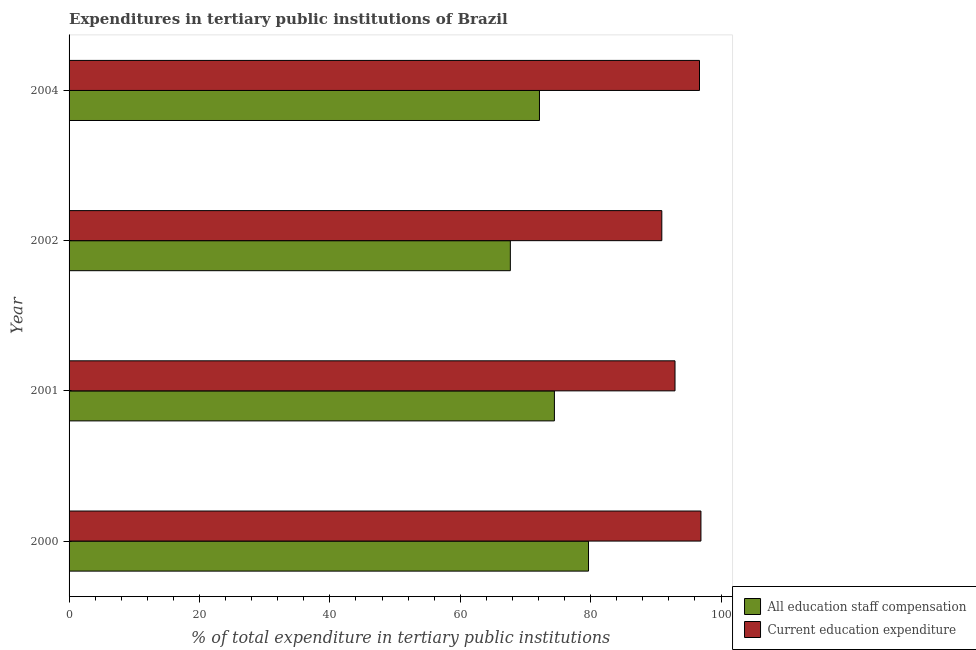How many different coloured bars are there?
Provide a short and direct response. 2. How many groups of bars are there?
Provide a succinct answer. 4. Are the number of bars per tick equal to the number of legend labels?
Your response must be concise. Yes. How many bars are there on the 4th tick from the top?
Your answer should be very brief. 2. In how many cases, is the number of bars for a given year not equal to the number of legend labels?
Give a very brief answer. 0. What is the expenditure in education in 2000?
Ensure brevity in your answer.  96.92. Across all years, what is the maximum expenditure in education?
Provide a short and direct response. 96.92. Across all years, what is the minimum expenditure in education?
Provide a succinct answer. 90.92. In which year was the expenditure in staff compensation maximum?
Your answer should be compact. 2000. What is the total expenditure in staff compensation in the graph?
Provide a succinct answer. 293.95. What is the difference between the expenditure in education in 2000 and that in 2001?
Your answer should be compact. 3.98. What is the difference between the expenditure in education in 2004 and the expenditure in staff compensation in 2000?
Offer a very short reply. 17.02. What is the average expenditure in staff compensation per year?
Your answer should be compact. 73.49. In the year 2000, what is the difference between the expenditure in staff compensation and expenditure in education?
Give a very brief answer. -17.24. In how many years, is the expenditure in education greater than 96 %?
Make the answer very short. 2. What is the ratio of the expenditure in education in 2000 to that in 2001?
Offer a terse response. 1.04. Is the expenditure in staff compensation in 2002 less than that in 2004?
Your answer should be compact. Yes. Is the difference between the expenditure in staff compensation in 2000 and 2002 greater than the difference between the expenditure in education in 2000 and 2002?
Ensure brevity in your answer.  Yes. What is the difference between the highest and the second highest expenditure in staff compensation?
Provide a succinct answer. 5.23. What is the difference between the highest and the lowest expenditure in staff compensation?
Your response must be concise. 11.99. In how many years, is the expenditure in staff compensation greater than the average expenditure in staff compensation taken over all years?
Provide a succinct answer. 2. Is the sum of the expenditure in staff compensation in 2001 and 2004 greater than the maximum expenditure in education across all years?
Provide a succinct answer. Yes. What does the 1st bar from the top in 2002 represents?
Your response must be concise. Current education expenditure. What does the 2nd bar from the bottom in 2002 represents?
Offer a very short reply. Current education expenditure. How many bars are there?
Offer a terse response. 8. Does the graph contain grids?
Keep it short and to the point. No. What is the title of the graph?
Your answer should be very brief. Expenditures in tertiary public institutions of Brazil. Does "Revenue" appear as one of the legend labels in the graph?
Your answer should be very brief. No. What is the label or title of the X-axis?
Give a very brief answer. % of total expenditure in tertiary public institutions. What is the label or title of the Y-axis?
Keep it short and to the point. Year. What is the % of total expenditure in tertiary public institutions of All education staff compensation in 2000?
Provide a short and direct response. 79.67. What is the % of total expenditure in tertiary public institutions of Current education expenditure in 2000?
Your answer should be compact. 96.92. What is the % of total expenditure in tertiary public institutions in All education staff compensation in 2001?
Offer a terse response. 74.44. What is the % of total expenditure in tertiary public institutions in Current education expenditure in 2001?
Provide a succinct answer. 92.94. What is the % of total expenditure in tertiary public institutions of All education staff compensation in 2002?
Provide a short and direct response. 67.68. What is the % of total expenditure in tertiary public institutions of Current education expenditure in 2002?
Provide a short and direct response. 90.92. What is the % of total expenditure in tertiary public institutions of All education staff compensation in 2004?
Your response must be concise. 72.15. What is the % of total expenditure in tertiary public institutions in Current education expenditure in 2004?
Provide a succinct answer. 96.7. Across all years, what is the maximum % of total expenditure in tertiary public institutions of All education staff compensation?
Offer a very short reply. 79.67. Across all years, what is the maximum % of total expenditure in tertiary public institutions in Current education expenditure?
Make the answer very short. 96.92. Across all years, what is the minimum % of total expenditure in tertiary public institutions of All education staff compensation?
Offer a very short reply. 67.68. Across all years, what is the minimum % of total expenditure in tertiary public institutions in Current education expenditure?
Provide a short and direct response. 90.92. What is the total % of total expenditure in tertiary public institutions of All education staff compensation in the graph?
Offer a very short reply. 293.95. What is the total % of total expenditure in tertiary public institutions of Current education expenditure in the graph?
Provide a succinct answer. 377.47. What is the difference between the % of total expenditure in tertiary public institutions of All education staff compensation in 2000 and that in 2001?
Give a very brief answer. 5.23. What is the difference between the % of total expenditure in tertiary public institutions of Current education expenditure in 2000 and that in 2001?
Offer a terse response. 3.98. What is the difference between the % of total expenditure in tertiary public institutions of All education staff compensation in 2000 and that in 2002?
Offer a very short reply. 11.99. What is the difference between the % of total expenditure in tertiary public institutions of Current education expenditure in 2000 and that in 2002?
Your answer should be very brief. 6. What is the difference between the % of total expenditure in tertiary public institutions of All education staff compensation in 2000 and that in 2004?
Give a very brief answer. 7.52. What is the difference between the % of total expenditure in tertiary public institutions in Current education expenditure in 2000 and that in 2004?
Your answer should be very brief. 0.22. What is the difference between the % of total expenditure in tertiary public institutions of All education staff compensation in 2001 and that in 2002?
Keep it short and to the point. 6.76. What is the difference between the % of total expenditure in tertiary public institutions of Current education expenditure in 2001 and that in 2002?
Provide a short and direct response. 2.02. What is the difference between the % of total expenditure in tertiary public institutions in All education staff compensation in 2001 and that in 2004?
Your answer should be very brief. 2.29. What is the difference between the % of total expenditure in tertiary public institutions of Current education expenditure in 2001 and that in 2004?
Ensure brevity in your answer.  -3.76. What is the difference between the % of total expenditure in tertiary public institutions of All education staff compensation in 2002 and that in 2004?
Give a very brief answer. -4.47. What is the difference between the % of total expenditure in tertiary public institutions of Current education expenditure in 2002 and that in 2004?
Your answer should be very brief. -5.78. What is the difference between the % of total expenditure in tertiary public institutions of All education staff compensation in 2000 and the % of total expenditure in tertiary public institutions of Current education expenditure in 2001?
Make the answer very short. -13.27. What is the difference between the % of total expenditure in tertiary public institutions of All education staff compensation in 2000 and the % of total expenditure in tertiary public institutions of Current education expenditure in 2002?
Your response must be concise. -11.24. What is the difference between the % of total expenditure in tertiary public institutions of All education staff compensation in 2000 and the % of total expenditure in tertiary public institutions of Current education expenditure in 2004?
Provide a succinct answer. -17.02. What is the difference between the % of total expenditure in tertiary public institutions of All education staff compensation in 2001 and the % of total expenditure in tertiary public institutions of Current education expenditure in 2002?
Offer a very short reply. -16.48. What is the difference between the % of total expenditure in tertiary public institutions in All education staff compensation in 2001 and the % of total expenditure in tertiary public institutions in Current education expenditure in 2004?
Provide a succinct answer. -22.26. What is the difference between the % of total expenditure in tertiary public institutions of All education staff compensation in 2002 and the % of total expenditure in tertiary public institutions of Current education expenditure in 2004?
Offer a very short reply. -29.01. What is the average % of total expenditure in tertiary public institutions in All education staff compensation per year?
Offer a very short reply. 73.49. What is the average % of total expenditure in tertiary public institutions of Current education expenditure per year?
Ensure brevity in your answer.  94.37. In the year 2000, what is the difference between the % of total expenditure in tertiary public institutions of All education staff compensation and % of total expenditure in tertiary public institutions of Current education expenditure?
Offer a very short reply. -17.24. In the year 2001, what is the difference between the % of total expenditure in tertiary public institutions in All education staff compensation and % of total expenditure in tertiary public institutions in Current education expenditure?
Your answer should be very brief. -18.5. In the year 2002, what is the difference between the % of total expenditure in tertiary public institutions in All education staff compensation and % of total expenditure in tertiary public institutions in Current education expenditure?
Provide a short and direct response. -23.23. In the year 2004, what is the difference between the % of total expenditure in tertiary public institutions of All education staff compensation and % of total expenditure in tertiary public institutions of Current education expenditure?
Ensure brevity in your answer.  -24.55. What is the ratio of the % of total expenditure in tertiary public institutions in All education staff compensation in 2000 to that in 2001?
Give a very brief answer. 1.07. What is the ratio of the % of total expenditure in tertiary public institutions of Current education expenditure in 2000 to that in 2001?
Give a very brief answer. 1.04. What is the ratio of the % of total expenditure in tertiary public institutions of All education staff compensation in 2000 to that in 2002?
Your answer should be very brief. 1.18. What is the ratio of the % of total expenditure in tertiary public institutions in Current education expenditure in 2000 to that in 2002?
Your answer should be compact. 1.07. What is the ratio of the % of total expenditure in tertiary public institutions of All education staff compensation in 2000 to that in 2004?
Offer a very short reply. 1.1. What is the ratio of the % of total expenditure in tertiary public institutions of Current education expenditure in 2000 to that in 2004?
Keep it short and to the point. 1. What is the ratio of the % of total expenditure in tertiary public institutions in All education staff compensation in 2001 to that in 2002?
Keep it short and to the point. 1.1. What is the ratio of the % of total expenditure in tertiary public institutions in Current education expenditure in 2001 to that in 2002?
Offer a very short reply. 1.02. What is the ratio of the % of total expenditure in tertiary public institutions in All education staff compensation in 2001 to that in 2004?
Give a very brief answer. 1.03. What is the ratio of the % of total expenditure in tertiary public institutions in Current education expenditure in 2001 to that in 2004?
Make the answer very short. 0.96. What is the ratio of the % of total expenditure in tertiary public institutions of All education staff compensation in 2002 to that in 2004?
Your answer should be compact. 0.94. What is the ratio of the % of total expenditure in tertiary public institutions in Current education expenditure in 2002 to that in 2004?
Offer a terse response. 0.94. What is the difference between the highest and the second highest % of total expenditure in tertiary public institutions of All education staff compensation?
Your answer should be very brief. 5.23. What is the difference between the highest and the second highest % of total expenditure in tertiary public institutions in Current education expenditure?
Provide a short and direct response. 0.22. What is the difference between the highest and the lowest % of total expenditure in tertiary public institutions of All education staff compensation?
Provide a succinct answer. 11.99. What is the difference between the highest and the lowest % of total expenditure in tertiary public institutions in Current education expenditure?
Offer a terse response. 6. 